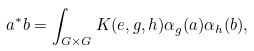<formula> <loc_0><loc_0><loc_500><loc_500>a ^ { * } b = \int _ { G \times G } K ( e , g , h ) \alpha _ { g } ( a ) \alpha _ { h } ( b ) ,</formula> 